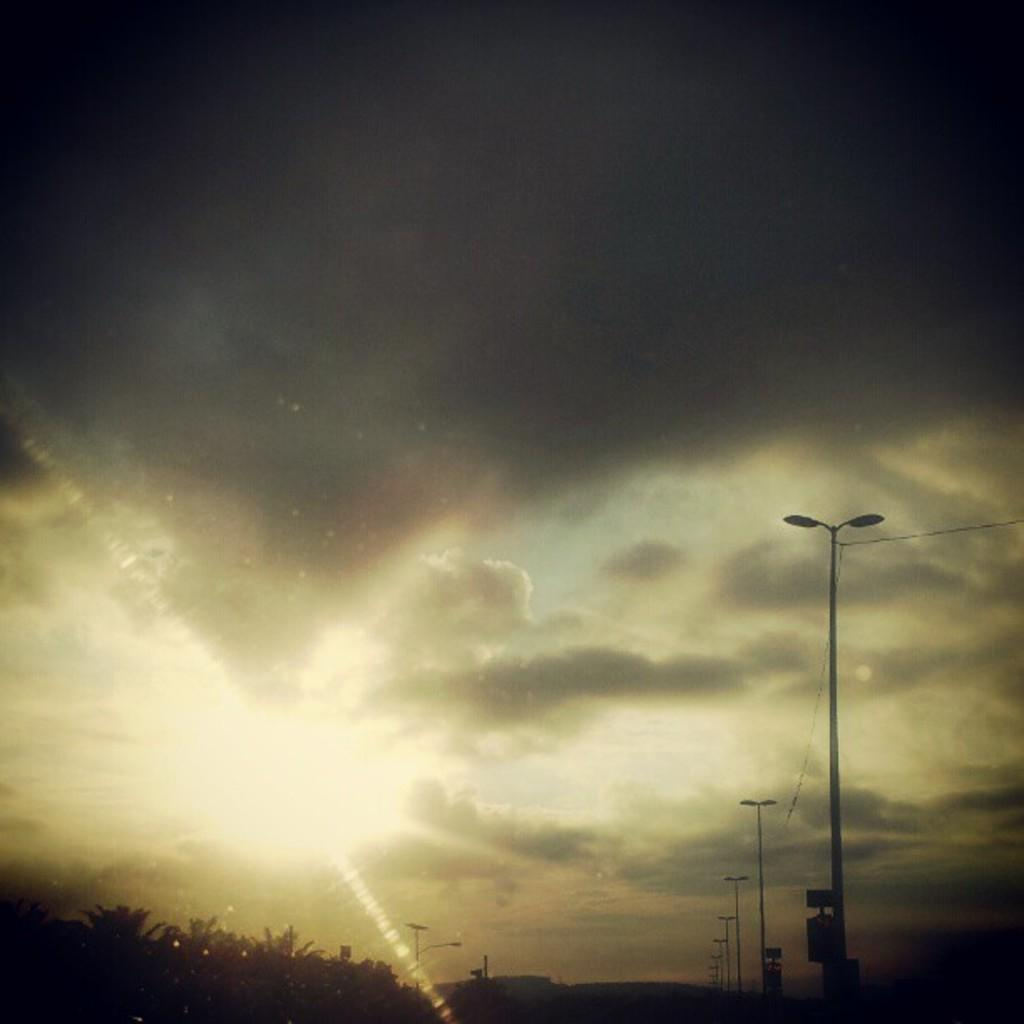What type of structures are present in the image? There are poles with wires in the image. What other natural elements can be seen in the image? There are trees in the image. What objects are made of wood in the image? There are boards in the image. What is visible in the background of the image? The sky is visible in the image. What can be observed in the sky? Clouds are present in the sky. What type of pencil can be seen being used to draw on the boards in the image? There is no pencil present in the image, and no drawing activity is taking place on the boards. 